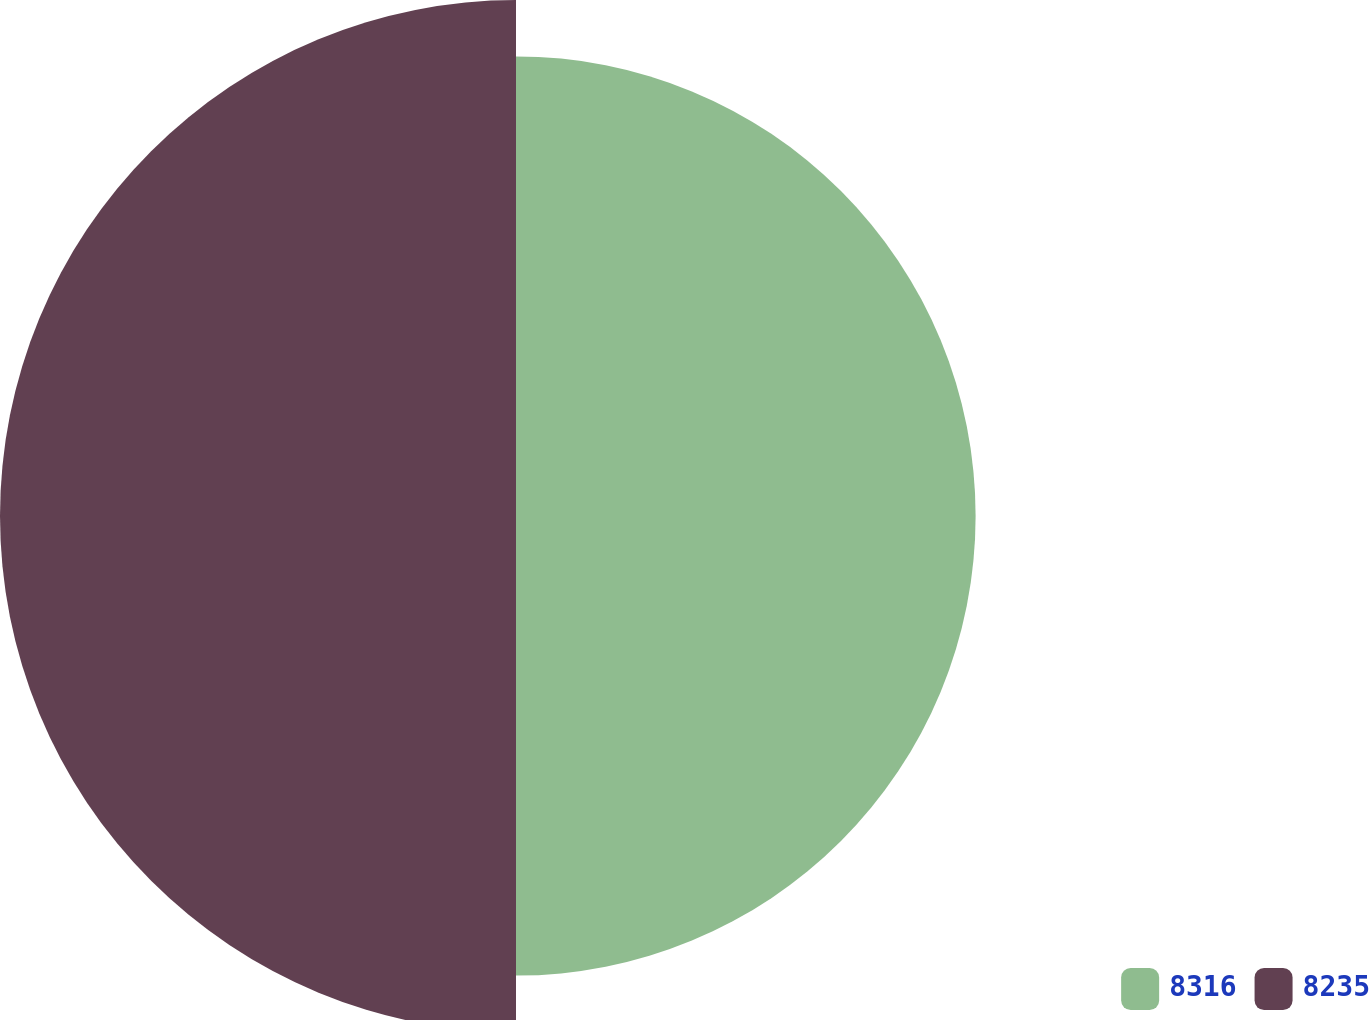Convert chart to OTSL. <chart><loc_0><loc_0><loc_500><loc_500><pie_chart><fcel>8316<fcel>8235<nl><fcel>47.11%<fcel>52.89%<nl></chart> 